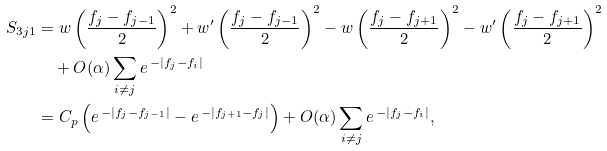<formula> <loc_0><loc_0><loc_500><loc_500>S _ { 3 j 1 } & = w \left ( \frac { f _ { j } - f _ { j - 1 } } { 2 } \right ) ^ { 2 } + w ^ { \prime } \left ( \frac { f _ { j } - f _ { j - 1 } } { 2 } \right ) ^ { 2 } - w \left ( \frac { f _ { j } - f _ { j + 1 } } { 2 } \right ) ^ { 2 } - w ^ { \prime } \left ( \frac { f _ { j } - f _ { j + 1 } } { 2 } \right ) ^ { 2 } \\ & \quad + O ( \alpha ) \sum _ { i \neq j } e ^ { \, - | f _ { j } - f _ { i } | } \\ & = C _ { p } \left ( e ^ { \, - | f _ { j } - f _ { j - 1 } | } - e ^ { \, - | f _ { j + 1 } - f _ { j } | } \right ) + O ( \alpha ) \sum _ { i \neq j } e ^ { \, - | f _ { j } - f _ { i } | } ,</formula> 